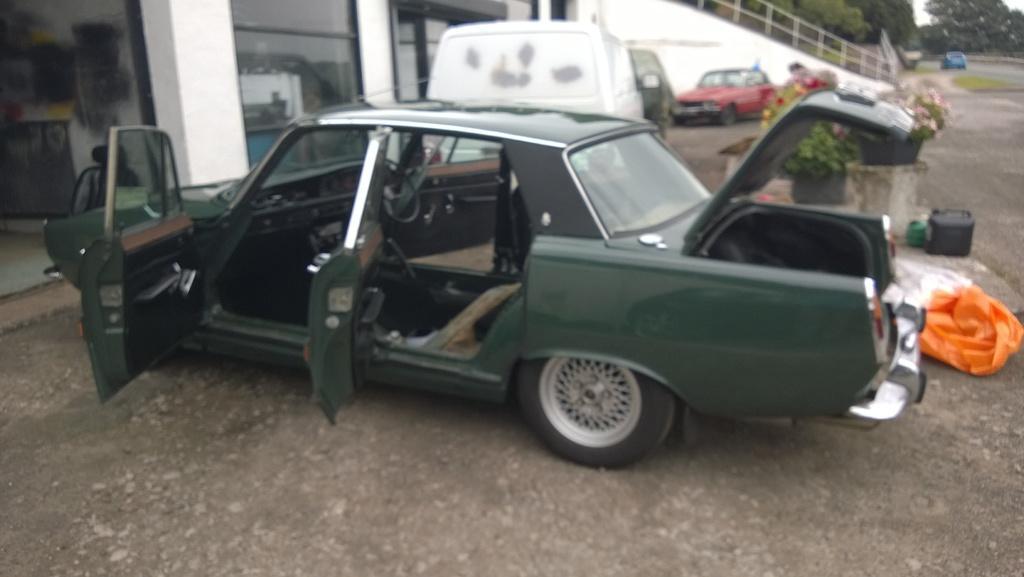Could you give a brief overview of what you see in this image? In this image I can see few vehicles, glass walls, flower pots, railing, few objects, plastic-covers and few trees. 